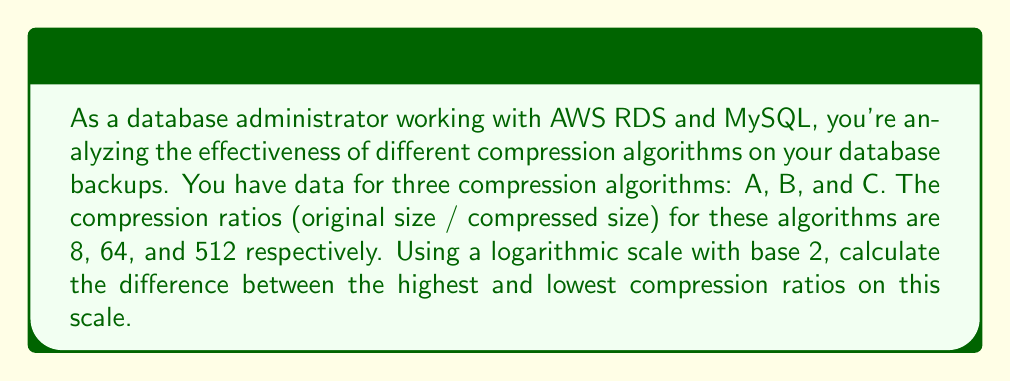What is the answer to this math problem? To solve this problem, we need to follow these steps:

1. Convert the compression ratios to a logarithmic scale with base 2.
2. Find the highest and lowest values on this scale.
3. Calculate the difference between these values.

Step 1: Converting to logarithmic scale (base 2)

For algorithm A: $\log_2(8) = 3$
For algorithm B: $\log_2(64) = 6$
For algorithm C: $\log_2(512) = 9$

We can verify these results:

$2^3 = 8$
$2^6 = 64$
$2^9 = 512$

Step 2: Identifying highest and lowest values

Lowest value: 3 (algorithm A)
Highest value: 9 (algorithm C)

Step 3: Calculating the difference

Difference = Highest value - Lowest value
           = 9 - 3
           = 6

This means that on a logarithmic scale with base 2, the difference between the highest and lowest compression ratios is 6.

To interpret this result: A difference of 6 on a log-2 scale means that the highest compression ratio (512) is $2^6 = 64$ times greater than the lowest compression ratio (8).
Answer: 6 